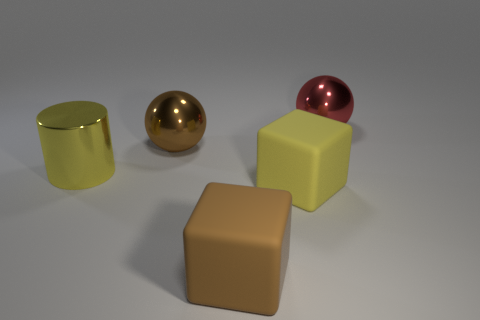Add 5 yellow cubes. How many objects exist? 10 Subtract all cubes. How many objects are left? 3 Add 1 large brown shiny cylinders. How many large brown shiny cylinders exist? 1 Subtract 0 cyan cylinders. How many objects are left? 5 Subtract all large brown matte objects. Subtract all large red things. How many objects are left? 3 Add 1 yellow things. How many yellow things are left? 3 